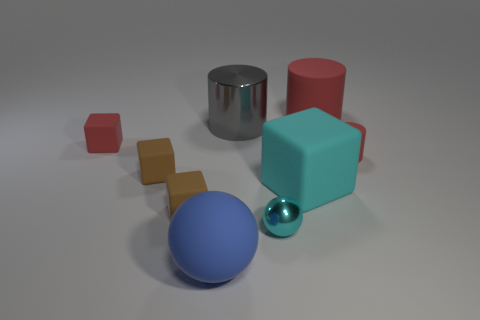There is a large block that is the same color as the metallic ball; what material is it?
Give a very brief answer. Rubber. Is the number of red matte objects to the right of the large red matte thing less than the number of tiny brown rubber objects that are to the left of the cyan metallic thing?
Your answer should be compact. Yes. How many things are either tiny red matte objects behind the tiny cylinder or blue cylinders?
Offer a terse response. 1. There is a big cyan object that is in front of the big shiny object that is to the right of the matte sphere; what is its shape?
Your answer should be compact. Cube. Are there any red objects of the same size as the blue thing?
Your response must be concise. Yes. Are there more tiny red matte things than big rubber objects?
Give a very brief answer. No. There is a red matte object to the left of the metallic cylinder; is its size the same as the ball that is right of the matte sphere?
Offer a very short reply. Yes. How many rubber objects are both in front of the cyan rubber cube and behind the blue rubber object?
Your answer should be compact. 1. What color is the other tiny shiny object that is the same shape as the blue object?
Give a very brief answer. Cyan. Is the number of big cyan rubber cubes less than the number of large purple matte cylinders?
Your answer should be very brief. No. 